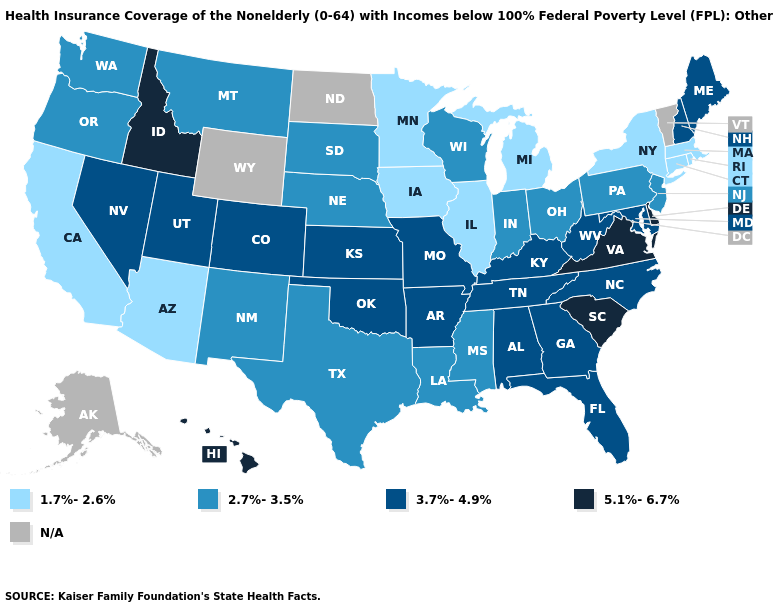What is the highest value in the USA?
Quick response, please. 5.1%-6.7%. Name the states that have a value in the range 5.1%-6.7%?
Concise answer only. Delaware, Hawaii, Idaho, South Carolina, Virginia. What is the highest value in the West ?
Answer briefly. 5.1%-6.7%. Which states have the lowest value in the USA?
Short answer required. Arizona, California, Connecticut, Illinois, Iowa, Massachusetts, Michigan, Minnesota, New York, Rhode Island. Name the states that have a value in the range 3.7%-4.9%?
Answer briefly. Alabama, Arkansas, Colorado, Florida, Georgia, Kansas, Kentucky, Maine, Maryland, Missouri, Nevada, New Hampshire, North Carolina, Oklahoma, Tennessee, Utah, West Virginia. What is the value of North Dakota?
Concise answer only. N/A. What is the lowest value in the MidWest?
Concise answer only. 1.7%-2.6%. Name the states that have a value in the range 2.7%-3.5%?
Keep it brief. Indiana, Louisiana, Mississippi, Montana, Nebraska, New Jersey, New Mexico, Ohio, Oregon, Pennsylvania, South Dakota, Texas, Washington, Wisconsin. Name the states that have a value in the range N/A?
Be succinct. Alaska, North Dakota, Vermont, Wyoming. Among the states that border Texas , does Arkansas have the lowest value?
Write a very short answer. No. What is the lowest value in the USA?
Be succinct. 1.7%-2.6%. Name the states that have a value in the range N/A?
Be succinct. Alaska, North Dakota, Vermont, Wyoming. Is the legend a continuous bar?
Give a very brief answer. No. 